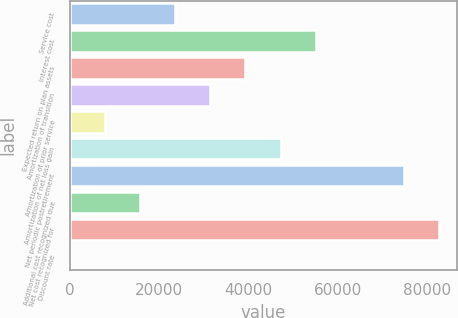<chart> <loc_0><loc_0><loc_500><loc_500><bar_chart><fcel>Service cost<fcel>Interest cost<fcel>Expected return on plan assets<fcel>Amortization of transition<fcel>Amortization of prior service<fcel>Amortization of net loss gain<fcel>Net periodic postretirement<fcel>Additional cost recognized due<fcel>Net cost recognized for<fcel>Discount rate<nl><fcel>23578.5<fcel>55060<fcel>39293.5<fcel>31436<fcel>7863.5<fcel>47151<fcel>74690<fcel>15721<fcel>82547.5<fcel>6<nl></chart> 